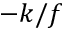<formula> <loc_0><loc_0><loc_500><loc_500>- k / f</formula> 